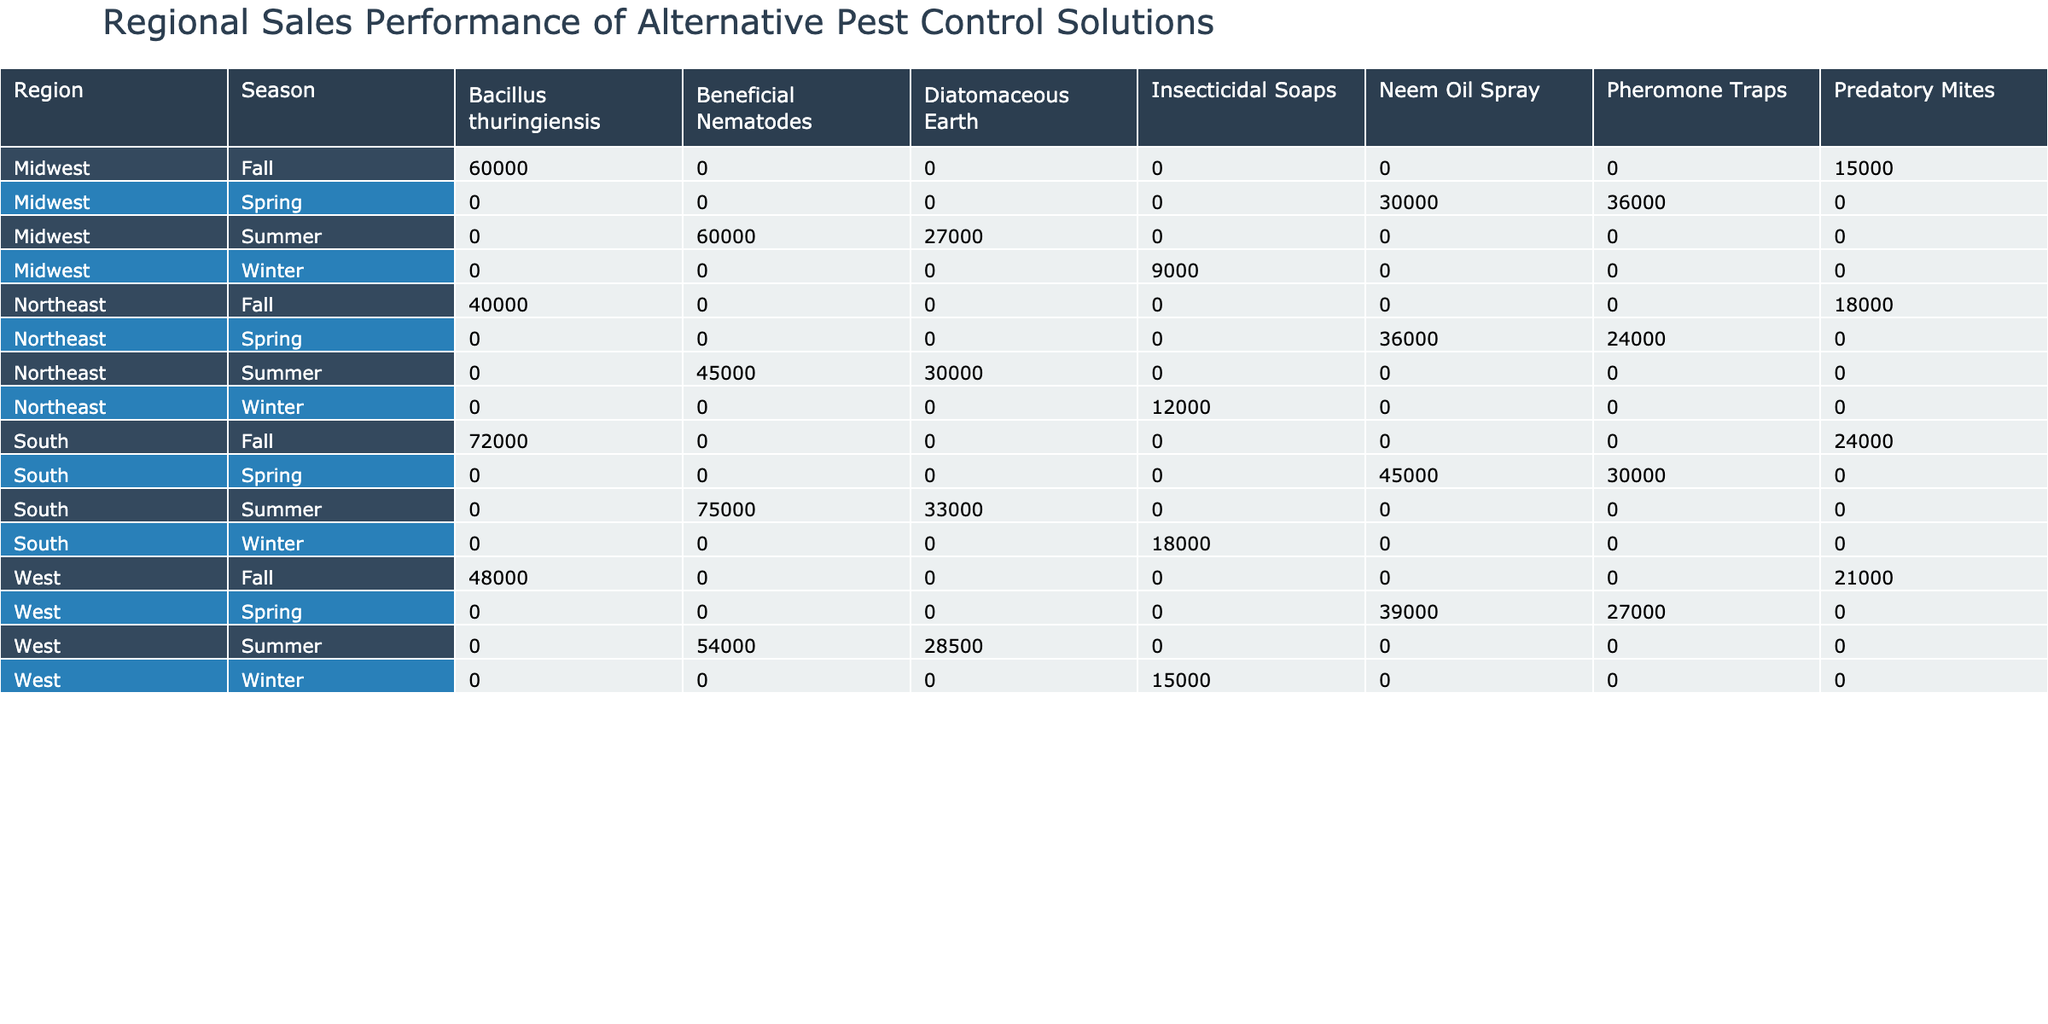What is the total revenue generated from Neem Oil Spray in the Northeast region during Spring? In the Northeast region, during Spring, the revenue generated from Neem Oil Spray is directly listed as 36,000.
Answer: 36,000 Which region had the highest sales volume for Beneficial Nematodes in Summer? The table shows that in Summer, the Midwest had 2,000 units of Beneficial Nematodes sold, while the South sold 2,500 units, making South the highest.
Answer: South Is the revenue from Diatomaceous Earth in the Midwest during Summer greater than that in the Northeast during Summer? In the Midwest, the revenue from Diatomaceous Earth in Summer is 27,000, while in the Northeast, it is 30,000, so Midwest does not exceed Northeast.
Answer: No What is the total revenue for Agricultural customer type in the Fall across all regions? Summing up the revenues for Agricultural customer type in the Fall: Northeast (40,000) + Midwest (60,000) + South (72,000) + West (48,000) gives 220,000 in total.
Answer: 220,000 In which season did the West region generate the least revenue from insecticidal soaps? The table shows that in Winter, the West generated 15,000 from insecticidal soaps, which is its only amount recorded for that product; thus, it's the least.
Answer: Winter 